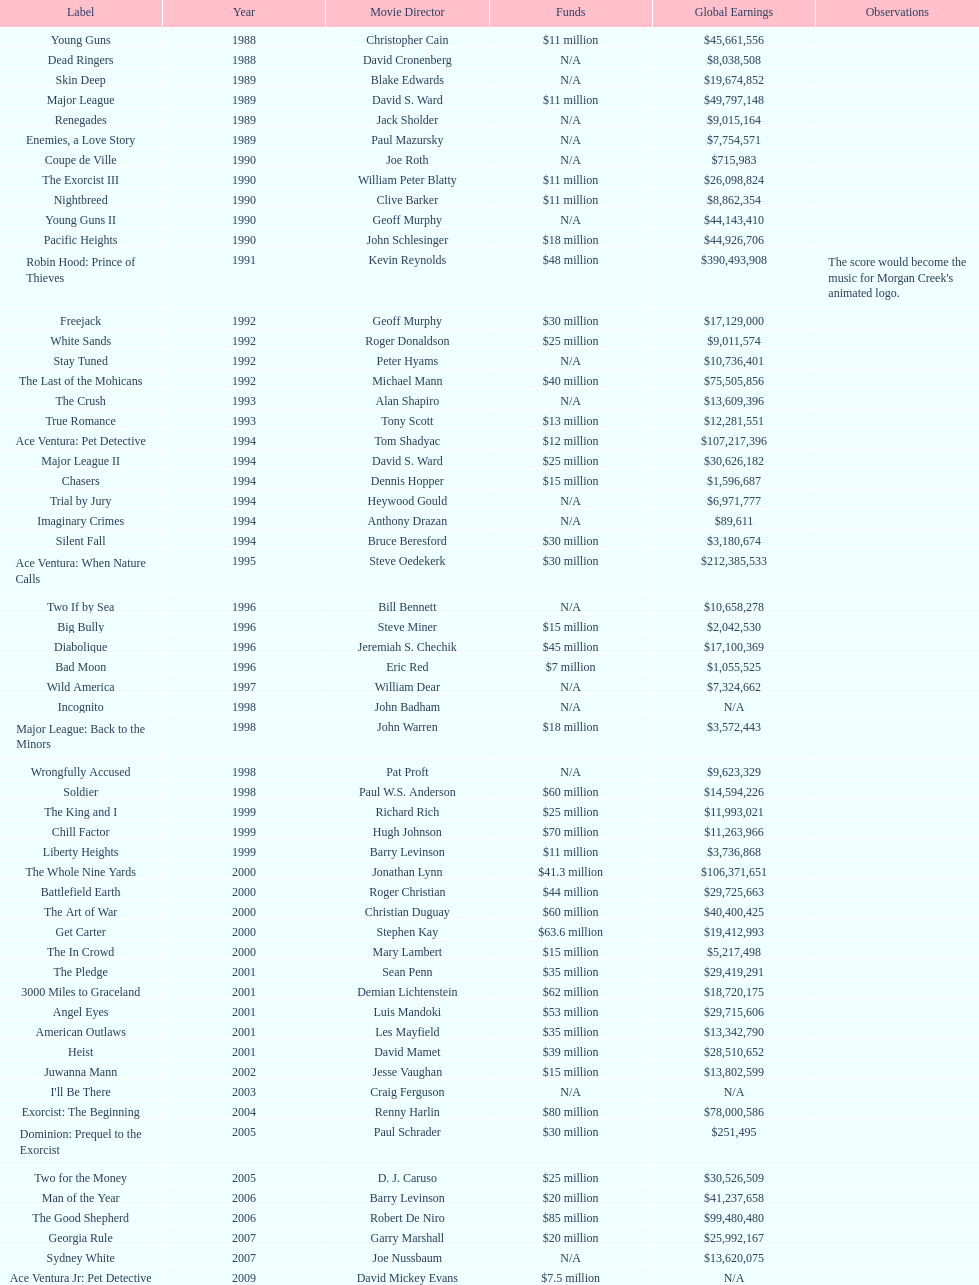Which morgan creek film grossed the most worldwide? Robin Hood: Prince of Thieves. 